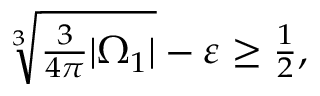<formula> <loc_0><loc_0><loc_500><loc_500>\begin{array} { r } { \sqrt { [ } 3 ] { \frac { 3 } { 4 \pi } | \Omega _ { 1 } | } - \varepsilon \geq \frac { 1 } { 2 } , } \end{array}</formula> 